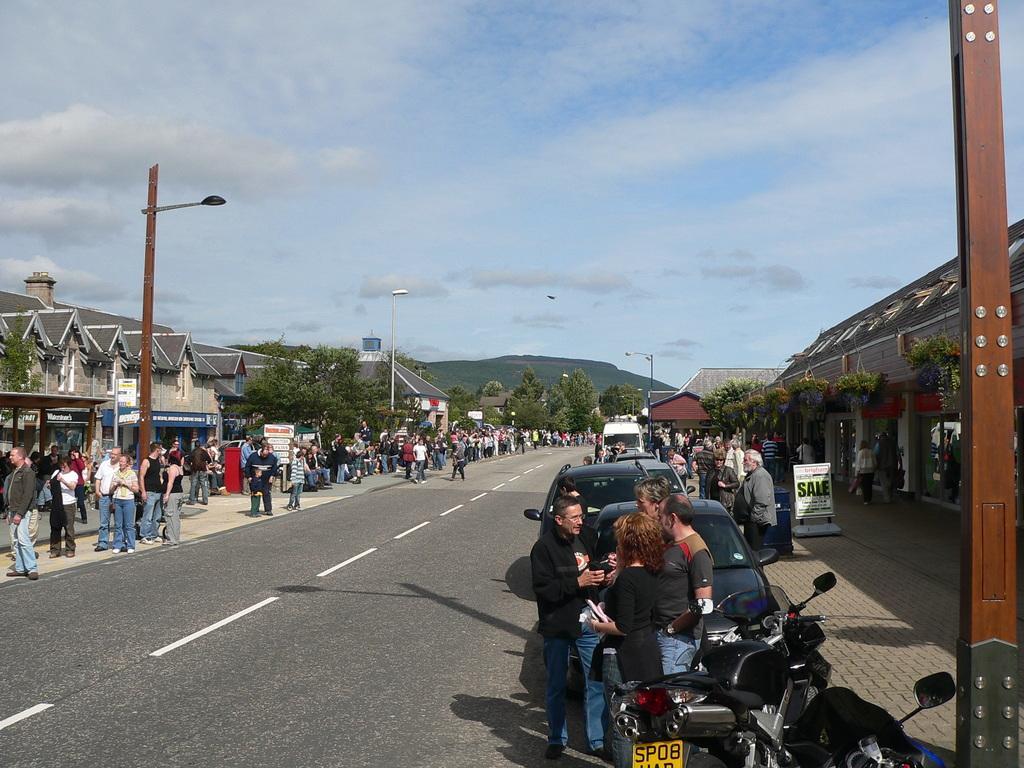How would you summarize this image in a sentence or two? This image is taken outdoors. At the top of the image there is the sky with clouds. At the bottom of the image there is road. In the background there is a hill and there are a few trees. There are two poles with street lights. On the left side of the image there are a few houses with walls, windows, roofs and doors. There are many boards with text on them. There are a few trees and there are a few poles which street lights. Many people are standing on the road and a few are walking. On the right side of the image there are a few houses. There are a few plants and trees. Many people are standing on the sidewalk and many vehicles are parked on the road. There is a board with a text on it and there are two poles with street lights. 